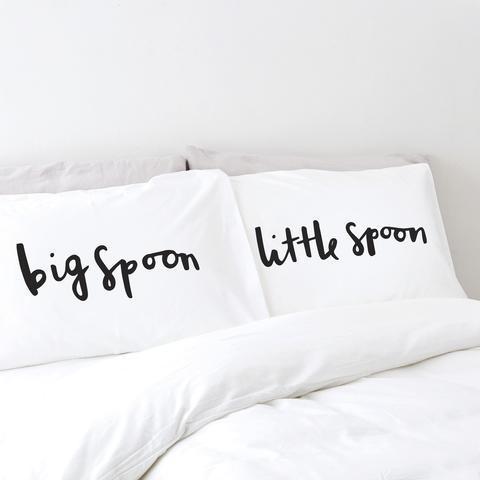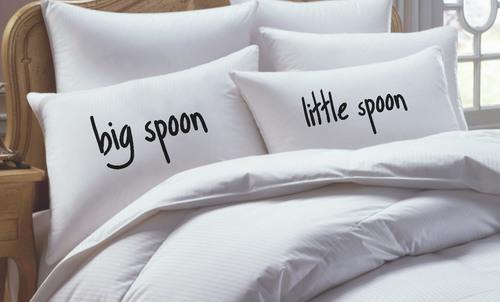The first image is the image on the left, the second image is the image on the right. Assess this claim about the two images: "A pair of pillows are printed with spoon shapes below lettering.". Correct or not? Answer yes or no. No. The first image is the image on the left, the second image is the image on the right. Assess this claim about the two images: "All big spoons are to the left.". Correct or not? Answer yes or no. Yes. 